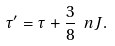Convert formula to latex. <formula><loc_0><loc_0><loc_500><loc_500>\tau ^ { \prime } = \tau + \frac { 3 } { 8 } \ n J .</formula> 